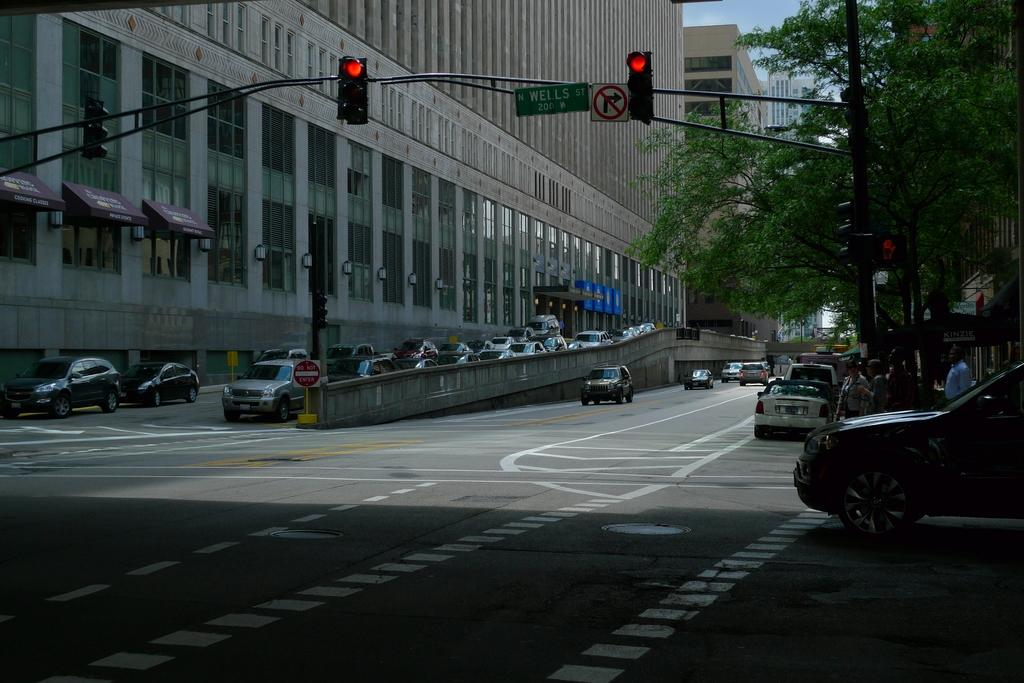<image>
Provide a brief description of the given image. A street with a stoplight at N WELLS ST with a building in the background. 